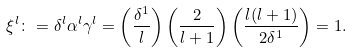<formula> <loc_0><loc_0><loc_500><loc_500>\xi ^ { l } \colon = \delta ^ { l } \alpha ^ { l } \gamma ^ { l } = \left ( \frac { \delta ^ { 1 } } { l } \right ) \left ( \frac { 2 } { l + 1 } \right ) \left ( \frac { l ( l + 1 ) } { 2 \delta ^ { 1 } } \right ) = 1 .</formula> 